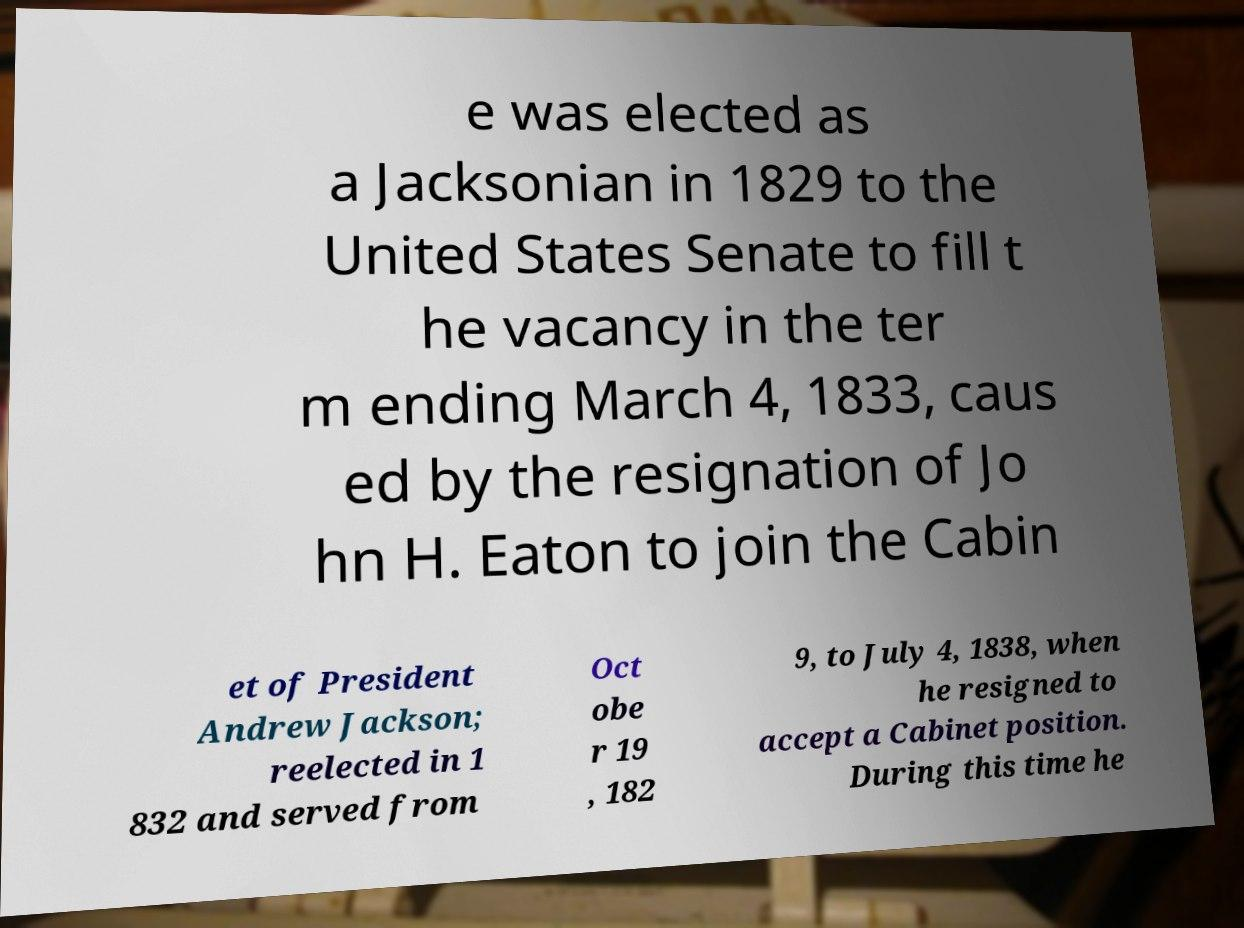What messages or text are displayed in this image? I need them in a readable, typed format. e was elected as a Jacksonian in 1829 to the United States Senate to fill t he vacancy in the ter m ending March 4, 1833, caus ed by the resignation of Jo hn H. Eaton to join the Cabin et of President Andrew Jackson; reelected in 1 832 and served from Oct obe r 19 , 182 9, to July 4, 1838, when he resigned to accept a Cabinet position. During this time he 